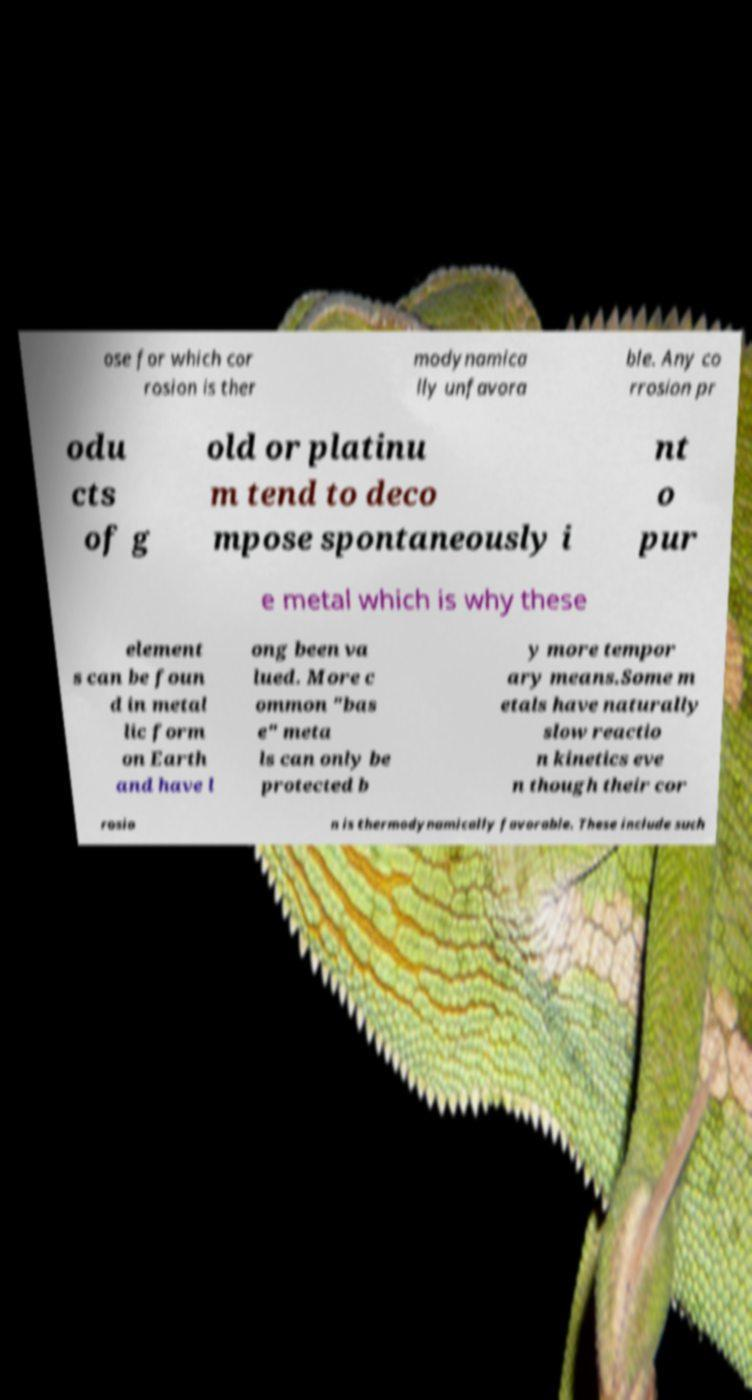Could you assist in decoding the text presented in this image and type it out clearly? ose for which cor rosion is ther modynamica lly unfavora ble. Any co rrosion pr odu cts of g old or platinu m tend to deco mpose spontaneously i nt o pur e metal which is why these element s can be foun d in metal lic form on Earth and have l ong been va lued. More c ommon "bas e" meta ls can only be protected b y more tempor ary means.Some m etals have naturally slow reactio n kinetics eve n though their cor rosio n is thermodynamically favorable. These include such 